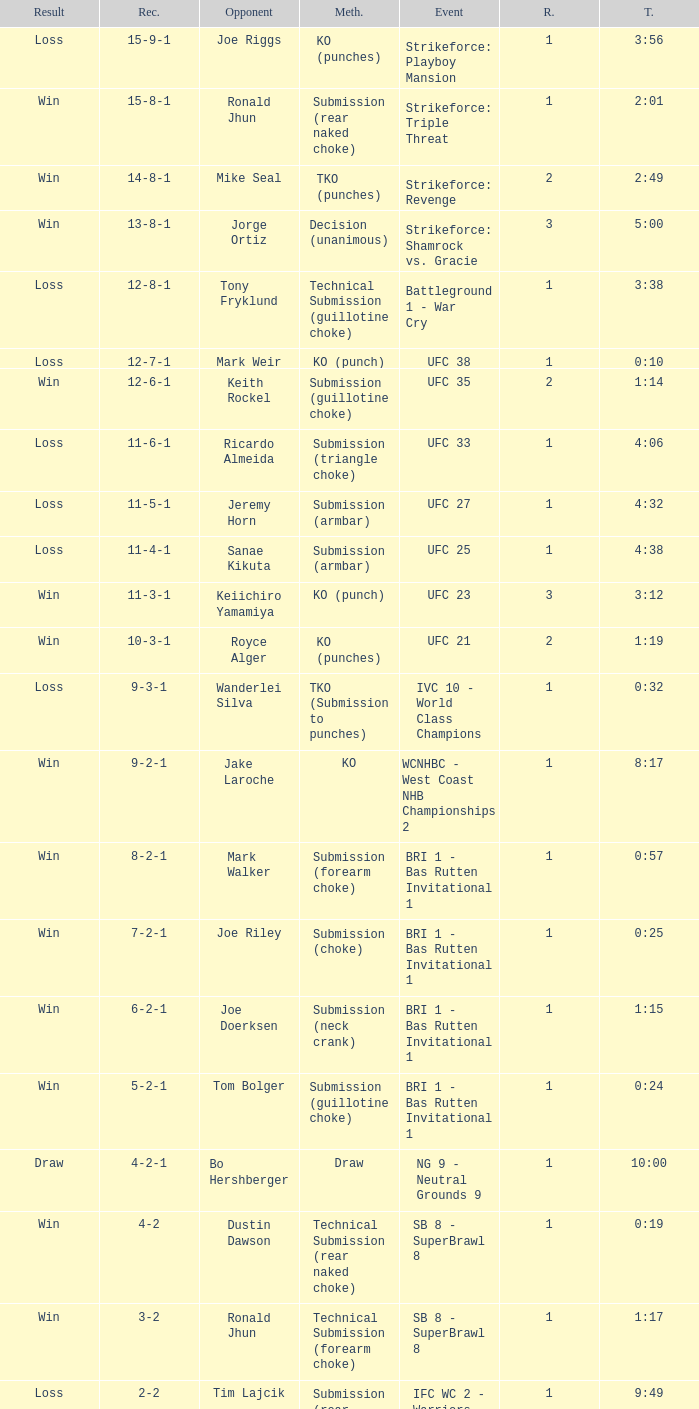What is the record during the event, UFC 27? 11-5-1. 